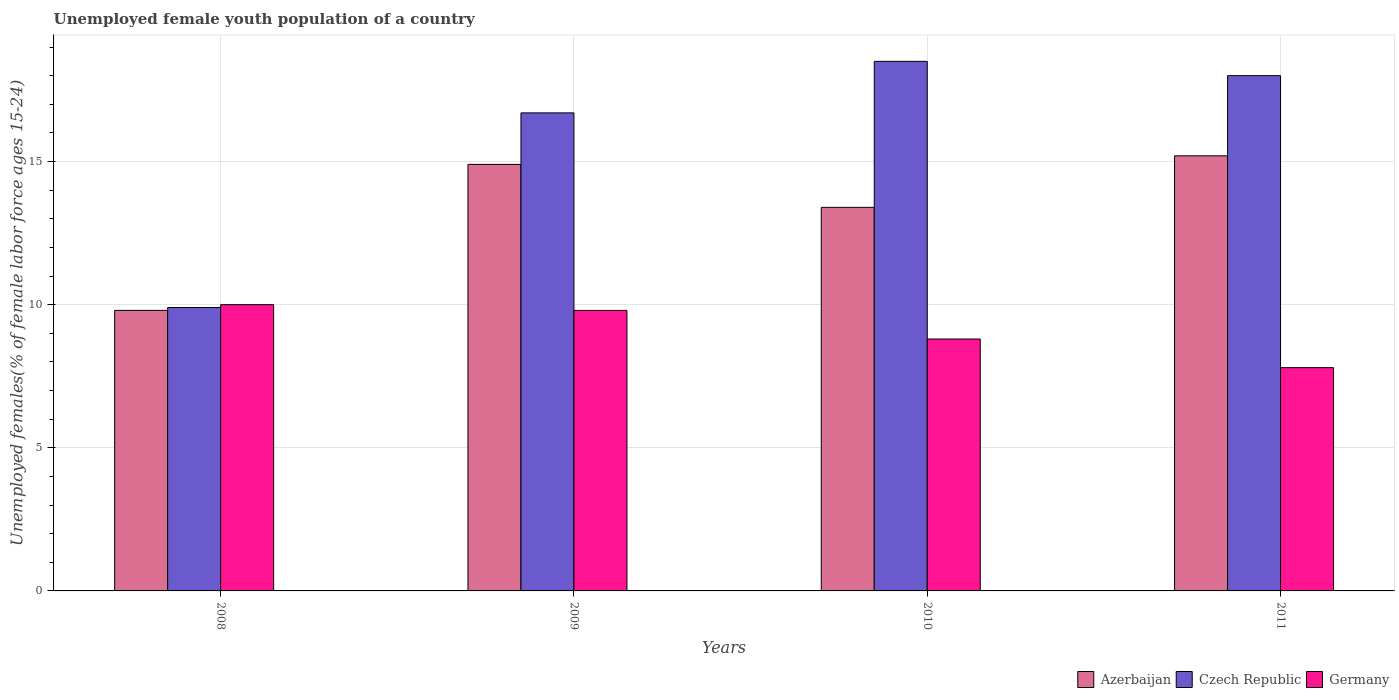How many different coloured bars are there?
Make the answer very short. 3. How many groups of bars are there?
Provide a succinct answer. 4. Are the number of bars on each tick of the X-axis equal?
Offer a terse response. Yes. What is the percentage of unemployed female youth population in Germany in 2008?
Offer a terse response. 10. Across all years, what is the minimum percentage of unemployed female youth population in Azerbaijan?
Your answer should be very brief. 9.8. In which year was the percentage of unemployed female youth population in Germany maximum?
Your answer should be compact. 2008. In which year was the percentage of unemployed female youth population in Czech Republic minimum?
Provide a succinct answer. 2008. What is the total percentage of unemployed female youth population in Czech Republic in the graph?
Your response must be concise. 63.1. What is the difference between the percentage of unemployed female youth population in Azerbaijan in 2009 and that in 2011?
Ensure brevity in your answer.  -0.3. What is the difference between the percentage of unemployed female youth population in Germany in 2011 and the percentage of unemployed female youth population in Czech Republic in 2009?
Give a very brief answer. -8.9. What is the average percentage of unemployed female youth population in Czech Republic per year?
Offer a terse response. 15.78. In the year 2009, what is the difference between the percentage of unemployed female youth population in Germany and percentage of unemployed female youth population in Czech Republic?
Ensure brevity in your answer.  -6.9. In how many years, is the percentage of unemployed female youth population in Czech Republic greater than 4 %?
Keep it short and to the point. 4. What is the ratio of the percentage of unemployed female youth population in Germany in 2009 to that in 2010?
Offer a very short reply. 1.11. Is the percentage of unemployed female youth population in Azerbaijan in 2008 less than that in 2010?
Provide a succinct answer. Yes. What is the difference between the highest and the second highest percentage of unemployed female youth population in Azerbaijan?
Give a very brief answer. 0.3. What is the difference between the highest and the lowest percentage of unemployed female youth population in Azerbaijan?
Offer a terse response. 5.4. Is the sum of the percentage of unemployed female youth population in Azerbaijan in 2008 and 2011 greater than the maximum percentage of unemployed female youth population in Czech Republic across all years?
Provide a succinct answer. Yes. What does the 3rd bar from the left in 2011 represents?
Keep it short and to the point. Germany. What does the 3rd bar from the right in 2011 represents?
Make the answer very short. Azerbaijan. Is it the case that in every year, the sum of the percentage of unemployed female youth population in Azerbaijan and percentage of unemployed female youth population in Czech Republic is greater than the percentage of unemployed female youth population in Germany?
Your answer should be very brief. Yes. Are all the bars in the graph horizontal?
Ensure brevity in your answer.  No. What is the difference between two consecutive major ticks on the Y-axis?
Give a very brief answer. 5. Are the values on the major ticks of Y-axis written in scientific E-notation?
Your answer should be compact. No. Does the graph contain grids?
Your answer should be very brief. Yes. Where does the legend appear in the graph?
Ensure brevity in your answer.  Bottom right. How many legend labels are there?
Ensure brevity in your answer.  3. What is the title of the graph?
Give a very brief answer. Unemployed female youth population of a country. What is the label or title of the X-axis?
Make the answer very short. Years. What is the label or title of the Y-axis?
Give a very brief answer. Unemployed females(% of female labor force ages 15-24). What is the Unemployed females(% of female labor force ages 15-24) in Azerbaijan in 2008?
Your answer should be compact. 9.8. What is the Unemployed females(% of female labor force ages 15-24) in Czech Republic in 2008?
Your response must be concise. 9.9. What is the Unemployed females(% of female labor force ages 15-24) of Germany in 2008?
Make the answer very short. 10. What is the Unemployed females(% of female labor force ages 15-24) in Azerbaijan in 2009?
Your answer should be compact. 14.9. What is the Unemployed females(% of female labor force ages 15-24) in Czech Republic in 2009?
Offer a very short reply. 16.7. What is the Unemployed females(% of female labor force ages 15-24) of Germany in 2009?
Your answer should be very brief. 9.8. What is the Unemployed females(% of female labor force ages 15-24) of Azerbaijan in 2010?
Your response must be concise. 13.4. What is the Unemployed females(% of female labor force ages 15-24) of Germany in 2010?
Make the answer very short. 8.8. What is the Unemployed females(% of female labor force ages 15-24) of Azerbaijan in 2011?
Provide a short and direct response. 15.2. What is the Unemployed females(% of female labor force ages 15-24) of Czech Republic in 2011?
Offer a terse response. 18. What is the Unemployed females(% of female labor force ages 15-24) of Germany in 2011?
Offer a terse response. 7.8. Across all years, what is the maximum Unemployed females(% of female labor force ages 15-24) in Azerbaijan?
Ensure brevity in your answer.  15.2. Across all years, what is the maximum Unemployed females(% of female labor force ages 15-24) in Czech Republic?
Your answer should be very brief. 18.5. Across all years, what is the minimum Unemployed females(% of female labor force ages 15-24) in Azerbaijan?
Offer a terse response. 9.8. Across all years, what is the minimum Unemployed females(% of female labor force ages 15-24) of Czech Republic?
Give a very brief answer. 9.9. Across all years, what is the minimum Unemployed females(% of female labor force ages 15-24) of Germany?
Give a very brief answer. 7.8. What is the total Unemployed females(% of female labor force ages 15-24) of Azerbaijan in the graph?
Your answer should be compact. 53.3. What is the total Unemployed females(% of female labor force ages 15-24) of Czech Republic in the graph?
Your response must be concise. 63.1. What is the total Unemployed females(% of female labor force ages 15-24) of Germany in the graph?
Keep it short and to the point. 36.4. What is the difference between the Unemployed females(% of female labor force ages 15-24) in Czech Republic in 2008 and that in 2009?
Your response must be concise. -6.8. What is the difference between the Unemployed females(% of female labor force ages 15-24) of Germany in 2008 and that in 2009?
Provide a succinct answer. 0.2. What is the difference between the Unemployed females(% of female labor force ages 15-24) in Czech Republic in 2008 and that in 2010?
Your response must be concise. -8.6. What is the difference between the Unemployed females(% of female labor force ages 15-24) in Azerbaijan in 2008 and that in 2011?
Ensure brevity in your answer.  -5.4. What is the difference between the Unemployed females(% of female labor force ages 15-24) in Germany in 2008 and that in 2011?
Provide a succinct answer. 2.2. What is the difference between the Unemployed females(% of female labor force ages 15-24) of Azerbaijan in 2009 and that in 2010?
Give a very brief answer. 1.5. What is the difference between the Unemployed females(% of female labor force ages 15-24) in Azerbaijan in 2009 and that in 2011?
Offer a terse response. -0.3. What is the difference between the Unemployed females(% of female labor force ages 15-24) in Czech Republic in 2010 and that in 2011?
Offer a very short reply. 0.5. What is the difference between the Unemployed females(% of female labor force ages 15-24) in Germany in 2010 and that in 2011?
Your answer should be compact. 1. What is the difference between the Unemployed females(% of female labor force ages 15-24) of Azerbaijan in 2008 and the Unemployed females(% of female labor force ages 15-24) of Czech Republic in 2009?
Your answer should be compact. -6.9. What is the difference between the Unemployed females(% of female labor force ages 15-24) of Azerbaijan in 2008 and the Unemployed females(% of female labor force ages 15-24) of Germany in 2009?
Keep it short and to the point. 0. What is the difference between the Unemployed females(% of female labor force ages 15-24) of Azerbaijan in 2008 and the Unemployed females(% of female labor force ages 15-24) of Czech Republic in 2011?
Offer a terse response. -8.2. What is the difference between the Unemployed females(% of female labor force ages 15-24) of Czech Republic in 2008 and the Unemployed females(% of female labor force ages 15-24) of Germany in 2011?
Offer a very short reply. 2.1. What is the difference between the Unemployed females(% of female labor force ages 15-24) in Azerbaijan in 2009 and the Unemployed females(% of female labor force ages 15-24) in Germany in 2010?
Your answer should be compact. 6.1. What is the difference between the Unemployed females(% of female labor force ages 15-24) of Czech Republic in 2009 and the Unemployed females(% of female labor force ages 15-24) of Germany in 2010?
Provide a short and direct response. 7.9. What is the difference between the Unemployed females(% of female labor force ages 15-24) in Czech Republic in 2009 and the Unemployed females(% of female labor force ages 15-24) in Germany in 2011?
Your answer should be very brief. 8.9. What is the difference between the Unemployed females(% of female labor force ages 15-24) in Azerbaijan in 2010 and the Unemployed females(% of female labor force ages 15-24) in Germany in 2011?
Provide a succinct answer. 5.6. What is the average Unemployed females(% of female labor force ages 15-24) of Azerbaijan per year?
Provide a short and direct response. 13.32. What is the average Unemployed females(% of female labor force ages 15-24) in Czech Republic per year?
Provide a succinct answer. 15.78. What is the average Unemployed females(% of female labor force ages 15-24) of Germany per year?
Ensure brevity in your answer.  9.1. In the year 2008, what is the difference between the Unemployed females(% of female labor force ages 15-24) in Azerbaijan and Unemployed females(% of female labor force ages 15-24) in Czech Republic?
Offer a very short reply. -0.1. In the year 2008, what is the difference between the Unemployed females(% of female labor force ages 15-24) in Czech Republic and Unemployed females(% of female labor force ages 15-24) in Germany?
Your response must be concise. -0.1. In the year 2009, what is the difference between the Unemployed females(% of female labor force ages 15-24) in Azerbaijan and Unemployed females(% of female labor force ages 15-24) in Germany?
Provide a short and direct response. 5.1. In the year 2009, what is the difference between the Unemployed females(% of female labor force ages 15-24) of Czech Republic and Unemployed females(% of female labor force ages 15-24) of Germany?
Ensure brevity in your answer.  6.9. In the year 2010, what is the difference between the Unemployed females(% of female labor force ages 15-24) of Azerbaijan and Unemployed females(% of female labor force ages 15-24) of Germany?
Offer a terse response. 4.6. In the year 2011, what is the difference between the Unemployed females(% of female labor force ages 15-24) of Azerbaijan and Unemployed females(% of female labor force ages 15-24) of Czech Republic?
Your response must be concise. -2.8. What is the ratio of the Unemployed females(% of female labor force ages 15-24) of Azerbaijan in 2008 to that in 2009?
Give a very brief answer. 0.66. What is the ratio of the Unemployed females(% of female labor force ages 15-24) in Czech Republic in 2008 to that in 2009?
Give a very brief answer. 0.59. What is the ratio of the Unemployed females(% of female labor force ages 15-24) of Germany in 2008 to that in 2009?
Offer a very short reply. 1.02. What is the ratio of the Unemployed females(% of female labor force ages 15-24) in Azerbaijan in 2008 to that in 2010?
Offer a very short reply. 0.73. What is the ratio of the Unemployed females(% of female labor force ages 15-24) in Czech Republic in 2008 to that in 2010?
Offer a terse response. 0.54. What is the ratio of the Unemployed females(% of female labor force ages 15-24) of Germany in 2008 to that in 2010?
Your response must be concise. 1.14. What is the ratio of the Unemployed females(% of female labor force ages 15-24) of Azerbaijan in 2008 to that in 2011?
Your response must be concise. 0.64. What is the ratio of the Unemployed females(% of female labor force ages 15-24) in Czech Republic in 2008 to that in 2011?
Provide a short and direct response. 0.55. What is the ratio of the Unemployed females(% of female labor force ages 15-24) in Germany in 2008 to that in 2011?
Keep it short and to the point. 1.28. What is the ratio of the Unemployed females(% of female labor force ages 15-24) in Azerbaijan in 2009 to that in 2010?
Your answer should be very brief. 1.11. What is the ratio of the Unemployed females(% of female labor force ages 15-24) in Czech Republic in 2009 to that in 2010?
Your answer should be very brief. 0.9. What is the ratio of the Unemployed females(% of female labor force ages 15-24) in Germany in 2009 to that in 2010?
Your answer should be compact. 1.11. What is the ratio of the Unemployed females(% of female labor force ages 15-24) of Azerbaijan in 2009 to that in 2011?
Make the answer very short. 0.98. What is the ratio of the Unemployed females(% of female labor force ages 15-24) of Czech Republic in 2009 to that in 2011?
Make the answer very short. 0.93. What is the ratio of the Unemployed females(% of female labor force ages 15-24) in Germany in 2009 to that in 2011?
Your response must be concise. 1.26. What is the ratio of the Unemployed females(% of female labor force ages 15-24) in Azerbaijan in 2010 to that in 2011?
Make the answer very short. 0.88. What is the ratio of the Unemployed females(% of female labor force ages 15-24) in Czech Republic in 2010 to that in 2011?
Ensure brevity in your answer.  1.03. What is the ratio of the Unemployed females(% of female labor force ages 15-24) of Germany in 2010 to that in 2011?
Ensure brevity in your answer.  1.13. What is the difference between the highest and the second highest Unemployed females(% of female labor force ages 15-24) in Germany?
Your response must be concise. 0.2. What is the difference between the highest and the lowest Unemployed females(% of female labor force ages 15-24) of Azerbaijan?
Offer a very short reply. 5.4. 